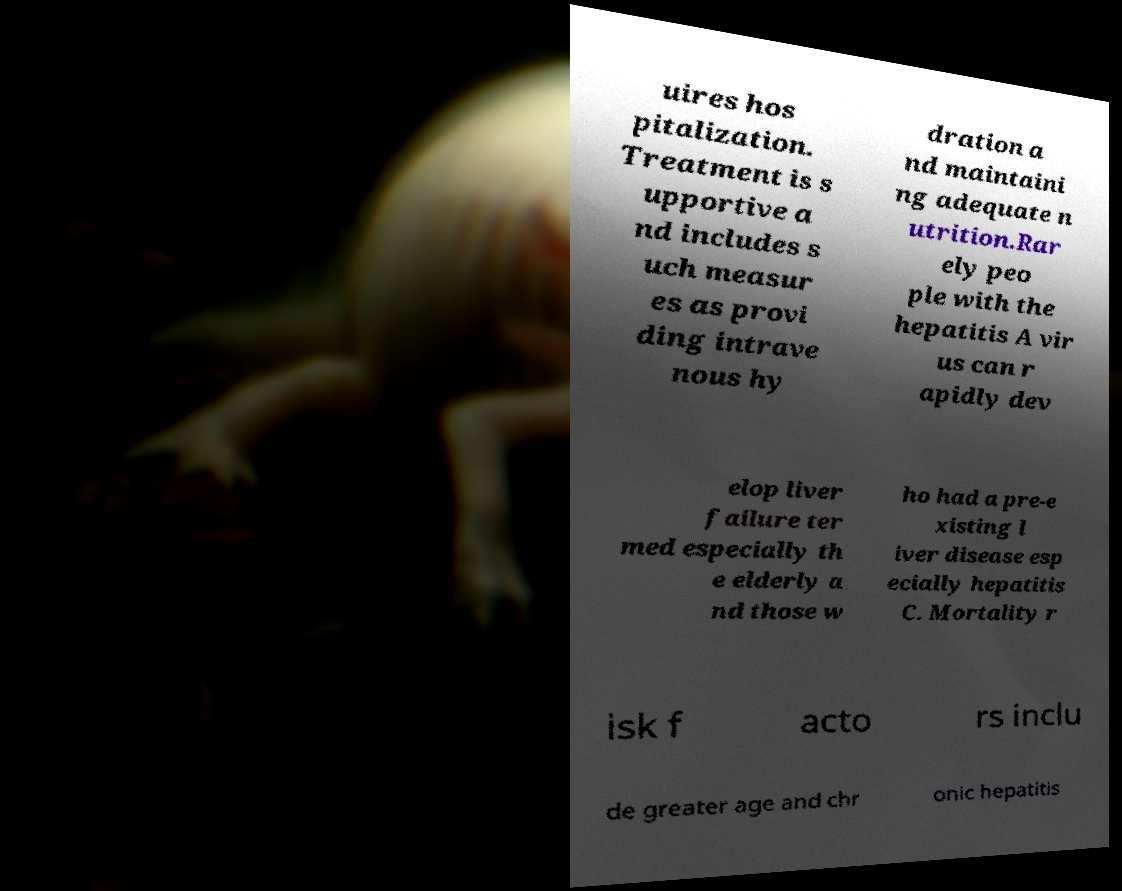Can you read and provide the text displayed in the image?This photo seems to have some interesting text. Can you extract and type it out for me? uires hos pitalization. Treatment is s upportive a nd includes s uch measur es as provi ding intrave nous hy dration a nd maintaini ng adequate n utrition.Rar ely peo ple with the hepatitis A vir us can r apidly dev elop liver failure ter med especially th e elderly a nd those w ho had a pre-e xisting l iver disease esp ecially hepatitis C. Mortality r isk f acto rs inclu de greater age and chr onic hepatitis 